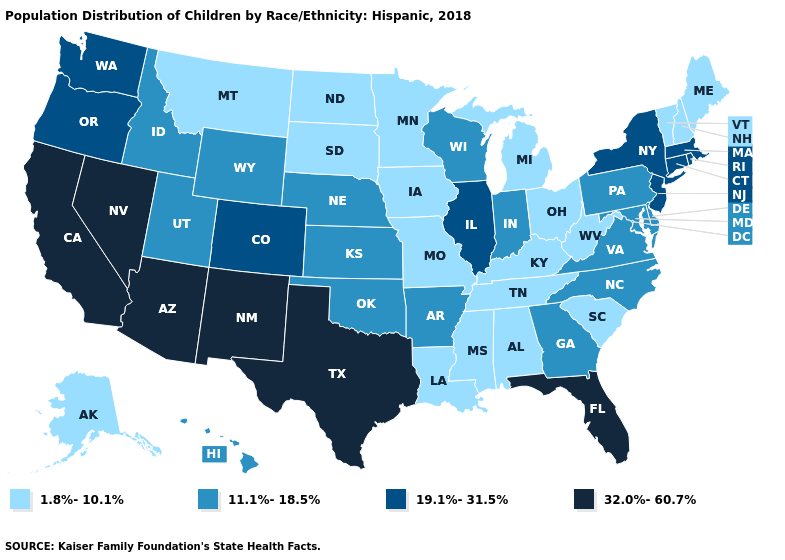What is the value of Alaska?
Keep it brief. 1.8%-10.1%. Name the states that have a value in the range 19.1%-31.5%?
Give a very brief answer. Colorado, Connecticut, Illinois, Massachusetts, New Jersey, New York, Oregon, Rhode Island, Washington. Does Wisconsin have the lowest value in the USA?
Write a very short answer. No. Among the states that border Oregon , does California have the highest value?
Be succinct. Yes. What is the highest value in the USA?
Be succinct. 32.0%-60.7%. Name the states that have a value in the range 1.8%-10.1%?
Concise answer only. Alabama, Alaska, Iowa, Kentucky, Louisiana, Maine, Michigan, Minnesota, Mississippi, Missouri, Montana, New Hampshire, North Dakota, Ohio, South Carolina, South Dakota, Tennessee, Vermont, West Virginia. Name the states that have a value in the range 1.8%-10.1%?
Write a very short answer. Alabama, Alaska, Iowa, Kentucky, Louisiana, Maine, Michigan, Minnesota, Mississippi, Missouri, Montana, New Hampshire, North Dakota, Ohio, South Carolina, South Dakota, Tennessee, Vermont, West Virginia. Which states have the lowest value in the Northeast?
Keep it brief. Maine, New Hampshire, Vermont. Among the states that border New York , does Connecticut have the lowest value?
Concise answer only. No. What is the value of Connecticut?
Short answer required. 19.1%-31.5%. Which states have the lowest value in the USA?
Give a very brief answer. Alabama, Alaska, Iowa, Kentucky, Louisiana, Maine, Michigan, Minnesota, Mississippi, Missouri, Montana, New Hampshire, North Dakota, Ohio, South Carolina, South Dakota, Tennessee, Vermont, West Virginia. Name the states that have a value in the range 32.0%-60.7%?
Answer briefly. Arizona, California, Florida, Nevada, New Mexico, Texas. What is the lowest value in states that border New Jersey?
Quick response, please. 11.1%-18.5%. Among the states that border North Dakota , which have the lowest value?
Give a very brief answer. Minnesota, Montana, South Dakota. 